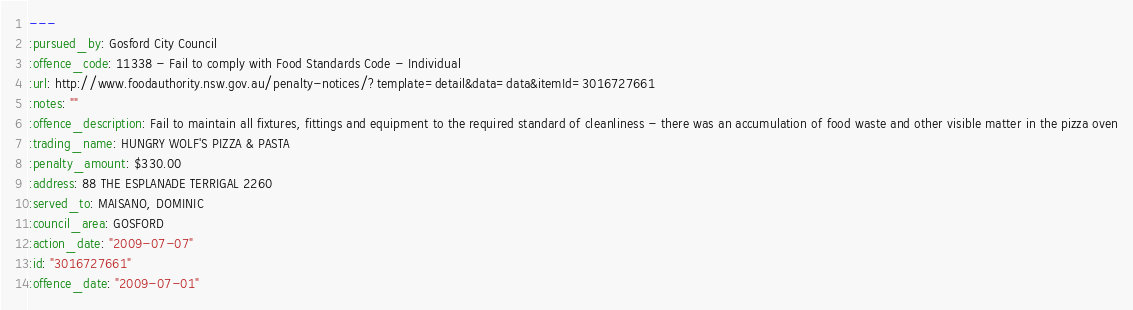Convert code to text. <code><loc_0><loc_0><loc_500><loc_500><_YAML_>--- 
:pursued_by: Gosford City Council
:offence_code: 11338 - Fail to comply with Food Standards Code - Individual
:url: http://www.foodauthority.nsw.gov.au/penalty-notices/?template=detail&data=data&itemId=3016727661
:notes: ""
:offence_description: Fail to maintain all fixtures, fittings and equipment to the required standard of cleanliness - there was an accumulation of food waste and other visible matter in the pizza oven
:trading_name: HUNGRY WOLF'S PIZZA & PASTA
:penalty_amount: $330.00
:address: 88 THE ESPLANADE TERRIGAL 2260
:served_to: MAISANO, DOMINIC
:council_area: GOSFORD
:action_date: "2009-07-07"
:id: "3016727661"
:offence_date: "2009-07-01"
</code> 